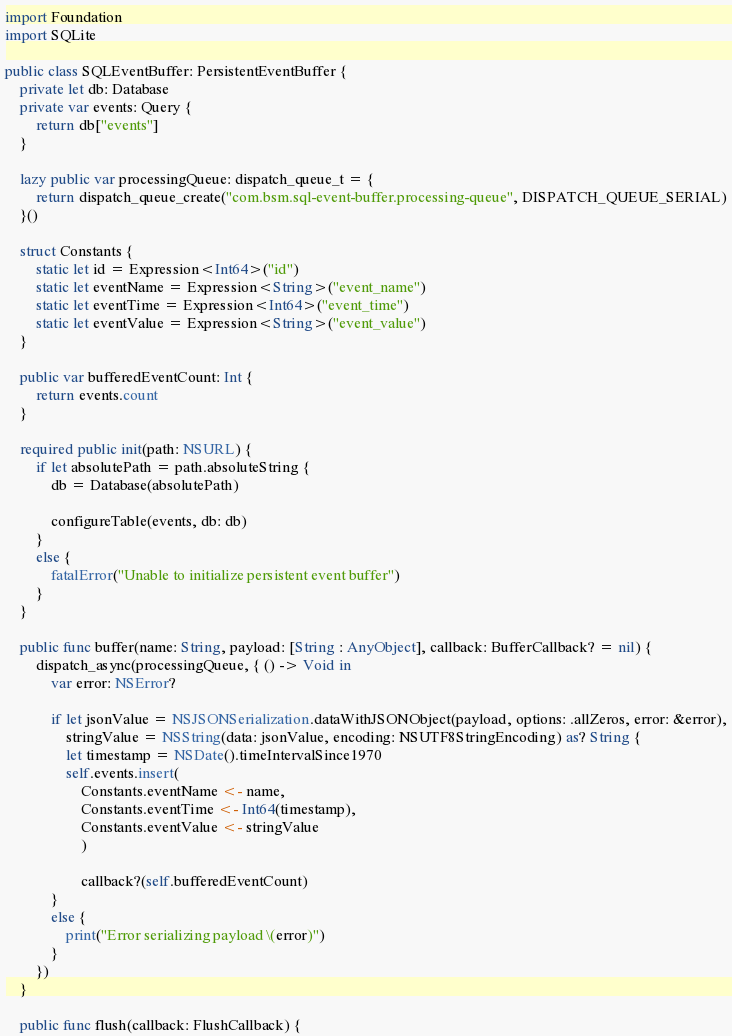Convert code to text. <code><loc_0><loc_0><loc_500><loc_500><_Swift_>import Foundation
import SQLite

public class SQLEventBuffer: PersistentEventBuffer {
    private let db: Database
    private var events: Query {
        return db["events"]
    }
    
    lazy public var processingQueue: dispatch_queue_t = {
        return dispatch_queue_create("com.bsm.sql-event-buffer.processing-queue", DISPATCH_QUEUE_SERIAL)
    }()

    struct Constants {
        static let id = Expression<Int64>("id")
        static let eventName = Expression<String>("event_name")
        static let eventTime = Expression<Int64>("event_time")
        static let eventValue = Expression<String>("event_value")
    }

    public var bufferedEventCount: Int {
        return events.count
    }

    required public init(path: NSURL) {
        if let absolutePath = path.absoluteString {
            db = Database(absolutePath)

            configureTable(events, db: db)
        }
        else {
            fatalError("Unable to initialize persistent event buffer")
        }
    }

    public func buffer(name: String, payload: [String : AnyObject], callback: BufferCallback? = nil) {
        dispatch_async(processingQueue, { () -> Void in
            var error: NSError?

            if let jsonValue = NSJSONSerialization.dataWithJSONObject(payload, options: .allZeros, error: &error),
                stringValue = NSString(data: jsonValue, encoding: NSUTF8StringEncoding) as? String {
                let timestamp = NSDate().timeIntervalSince1970
                self.events.insert(
                    Constants.eventName <- name,
                    Constants.eventTime <- Int64(timestamp),
                    Constants.eventValue <- stringValue
                    )

                    callback?(self.bufferedEventCount)
            }
            else {
                print("Error serializing payload \(error)")
            }
        })
    }

    public func flush(callback: FlushCallback) {</code> 